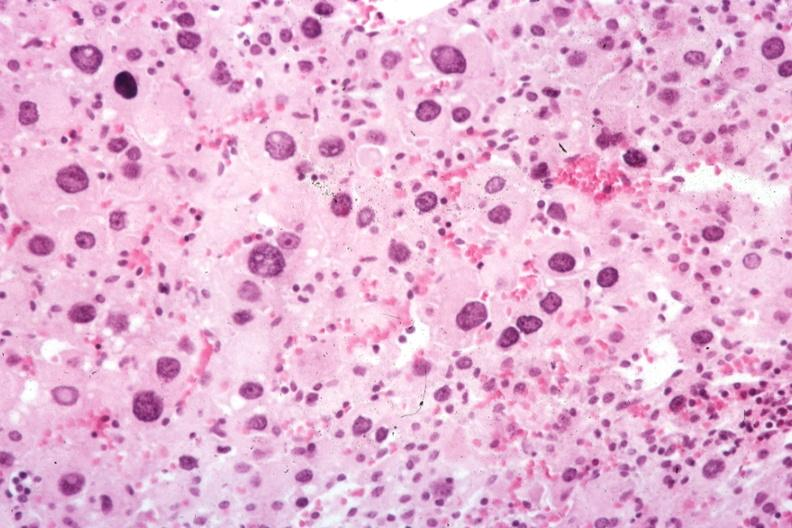what is present?
Answer the question using a single word or phrase. Cytomegaly 